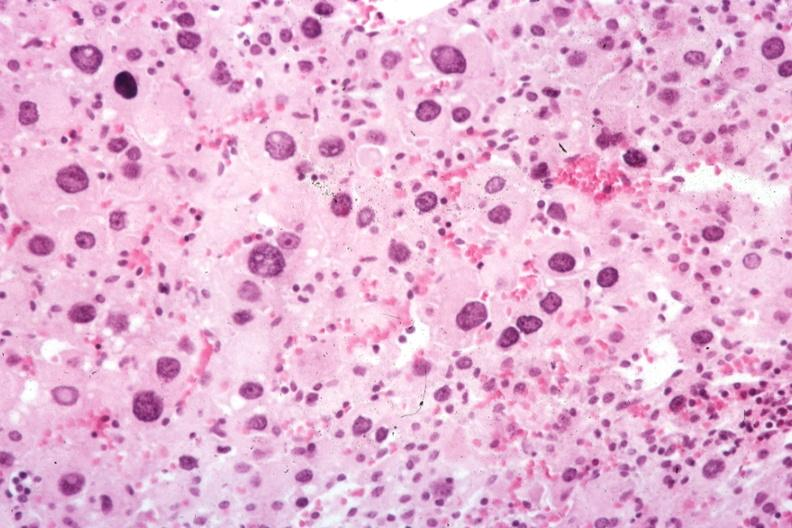what is present?
Answer the question using a single word or phrase. Cytomegaly 